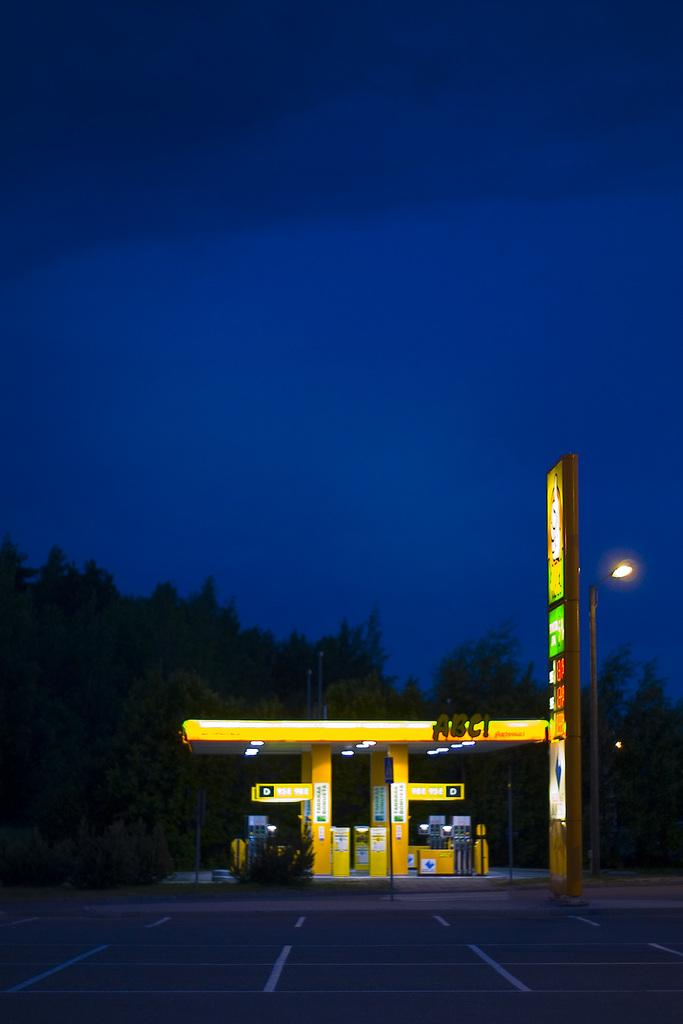Provide a one-sentence caption for the provided image. A yellow ABC! Service Station with a sign at the entrance. 